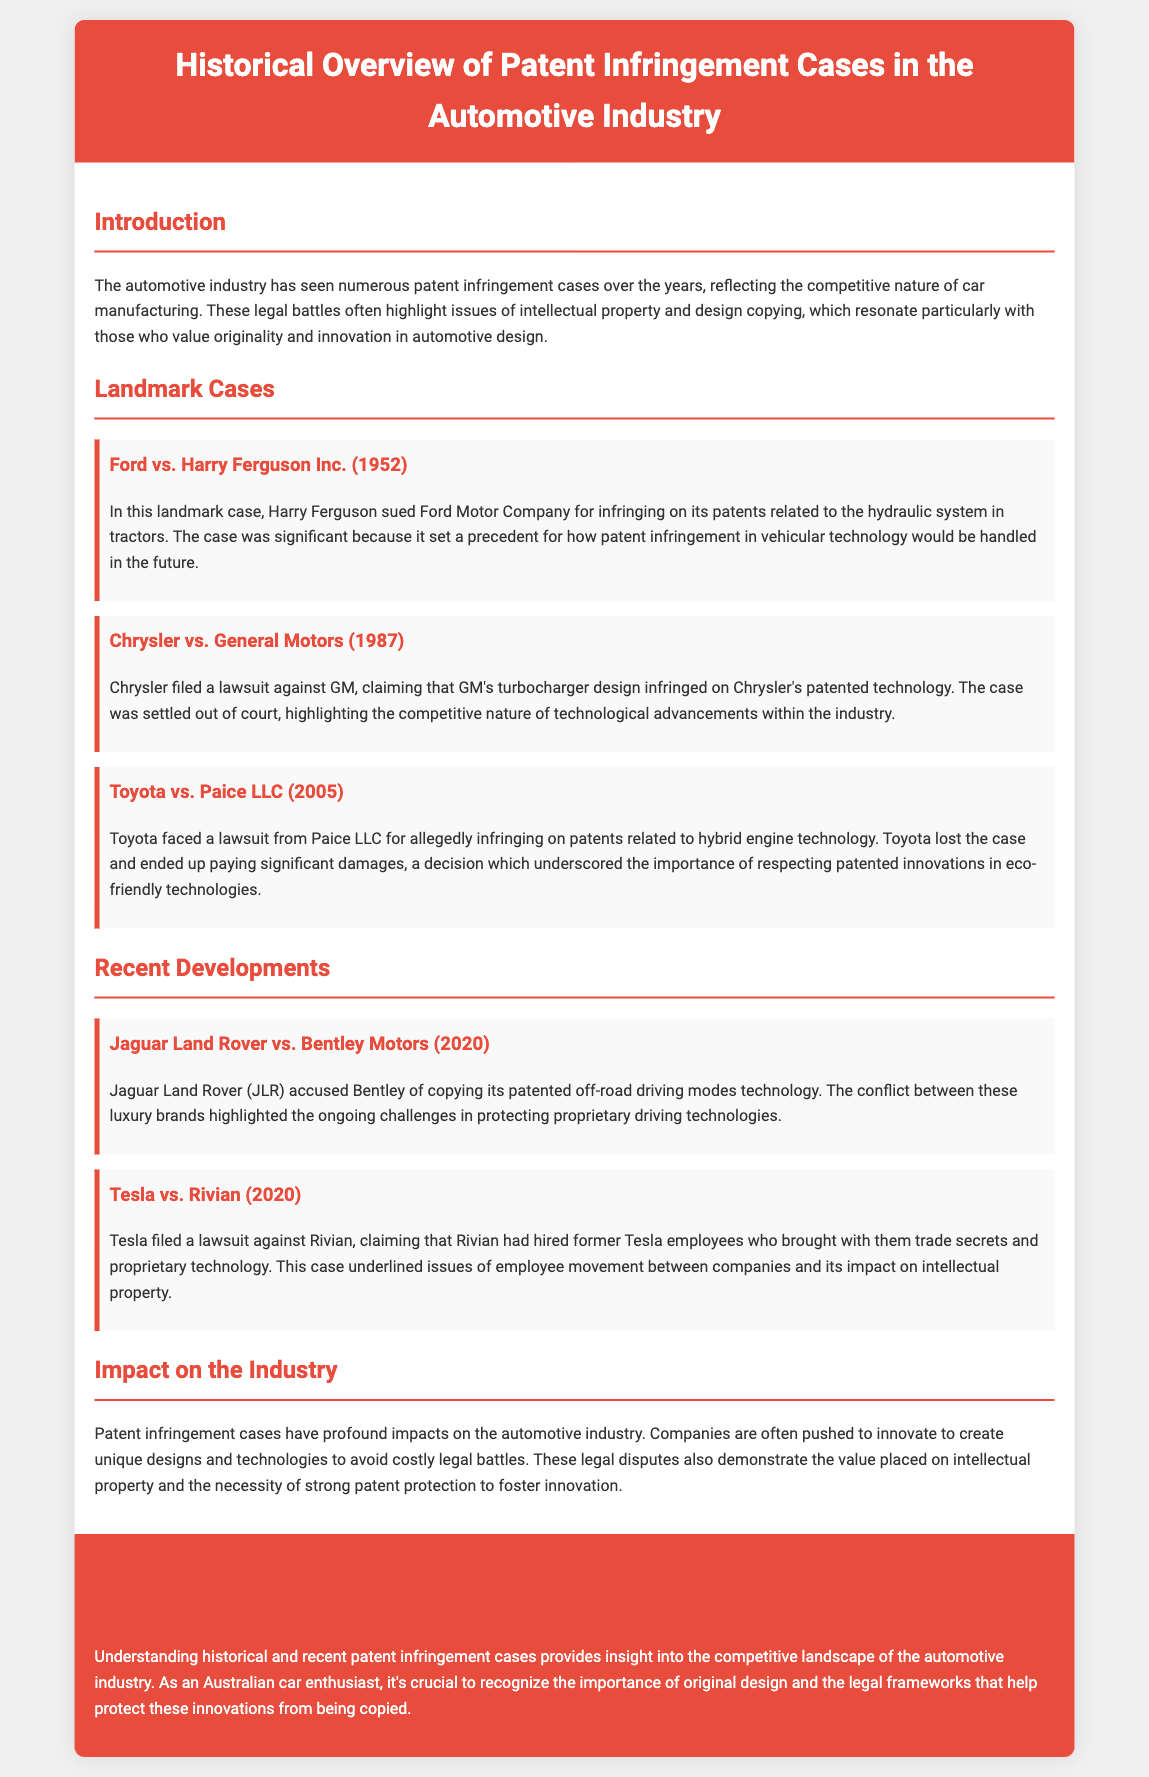What case involved Ford and Harry Ferguson? The document mentions that the case is titled "Ford vs. Harry Ferguson Inc. (1952)", which highlights its significance in patent infringement related to vehicular technology.
Answer: Ford vs. Harry Ferguson Inc What year was Chrysler's case against General Motors? The document states that Chrysler filed the lawsuit against GM in the year 1987.
Answer: 1987 Who sued Toyota in 2005? According to the document, Paice LLC sued Toyota over patent infringement related to hybrid engine technology.
Answer: Paice LLC What technology was at the center of the Jaguar Land Rover case? The document states that Jaguar Land Rover accused Bentley of copying its patented off-road driving modes technology.
Answer: Off-road driving modes technology What did Tesla claim Rivian did? The document indicates that Tesla claimed Rivian hired former Tesla employees who brought proprietary technology and trade secrets.
Answer: Hired former employees How have patent infringement cases affected industry innovation? The document explains that such legal disputes push companies to innovate to create unique designs and technologies.
Answer: Companies are pushed to innovate What was the outcome of the Toyota vs. Paice LLC case? The document mentions that Toyota lost the case and paid significant damages.
Answer: Toyota lost What is a key theme in the conclusion of the document? The conclusion emphasizes the importance of originality in design and protecting automotive innovations from copying.
Answer: Original design What does the introduction state about the competitive nature of the automotive industry? The introduction notes that the competitive nature of car manufacturing has led to numerous patent infringement cases.
Answer: Numerous patent infringement cases 